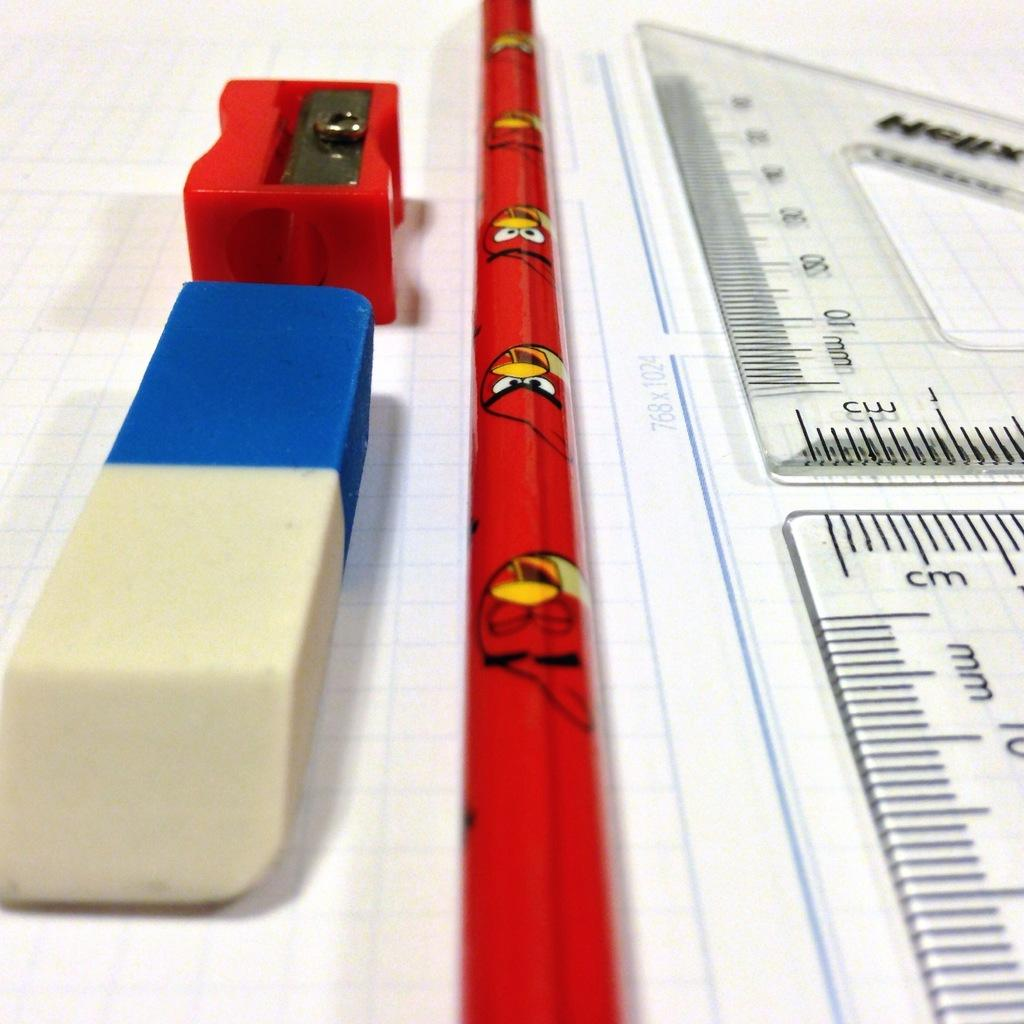<image>
Provide a brief description of the given image. A roll of angry bird wrapping paper and drawing supplies with a 768x1024 measurement. 